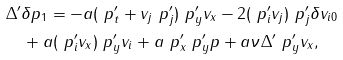Convert formula to latex. <formula><loc_0><loc_0><loc_500><loc_500>& \Delta ^ { \prime } \delta p _ { 1 } = - a ( \ p _ { t } ^ { \prime } + v _ { j } \ p _ { j } ^ { \prime } ) \ p _ { y } ^ { \prime } v _ { x } - 2 ( \ p _ { i } ^ { \prime } v _ { j } ) \ p _ { j } ^ { \prime } \delta v _ { i 0 } \\ & \quad + a ( \ p _ { i } ^ { \prime } v _ { x } ) \ p _ { y } ^ { \prime } v _ { i } + a \ p _ { x } ^ { \prime } \ p _ { y } ^ { \prime } p + a \nu \Delta ^ { \prime } \ p _ { y } ^ { \prime } v _ { x } ,</formula> 